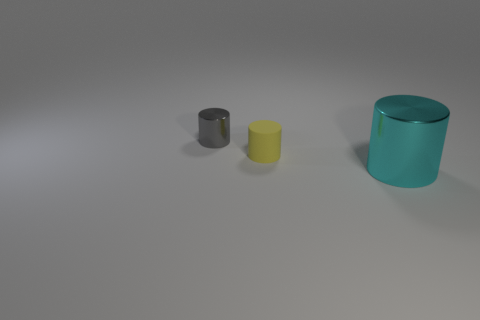Subtract all yellow cylinders. How many cylinders are left? 2 Add 2 yellow rubber objects. How many objects exist? 5 Subtract all big cyan cylinders. How many cylinders are left? 2 Subtract all purple shiny spheres. Subtract all yellow cylinders. How many objects are left? 2 Add 1 small objects. How many small objects are left? 3 Add 1 small matte objects. How many small matte objects exist? 2 Subtract 0 blue balls. How many objects are left? 3 Subtract 2 cylinders. How many cylinders are left? 1 Subtract all cyan cylinders. Subtract all brown spheres. How many cylinders are left? 2 Subtract all yellow cubes. How many red cylinders are left? 0 